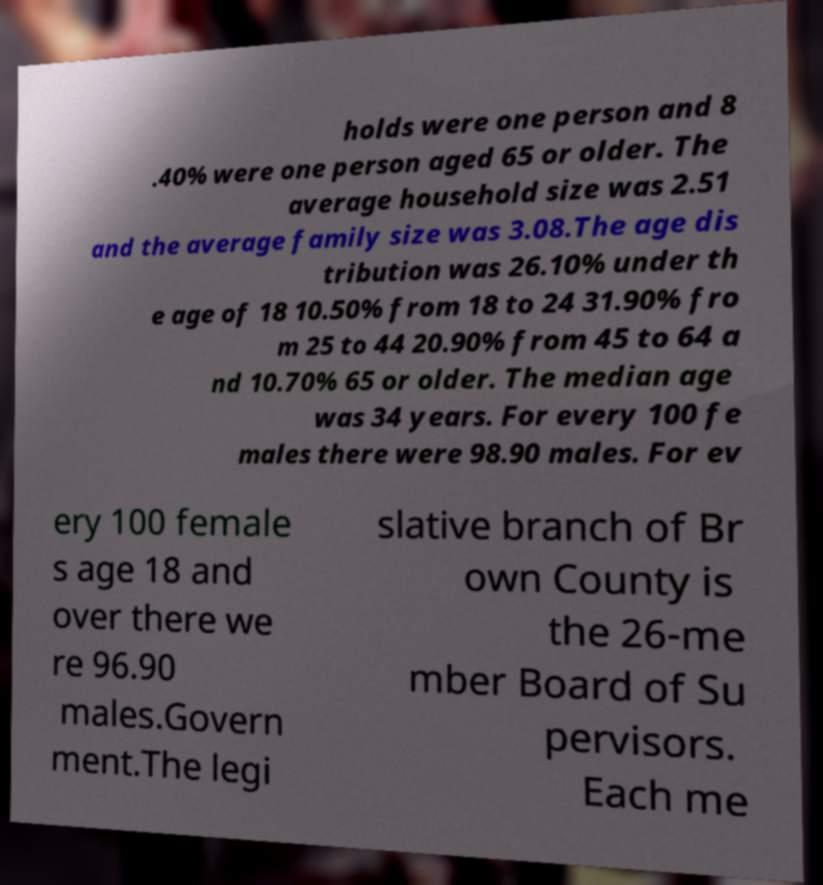For documentation purposes, I need the text within this image transcribed. Could you provide that? holds were one person and 8 .40% were one person aged 65 or older. The average household size was 2.51 and the average family size was 3.08.The age dis tribution was 26.10% under th e age of 18 10.50% from 18 to 24 31.90% fro m 25 to 44 20.90% from 45 to 64 a nd 10.70% 65 or older. The median age was 34 years. For every 100 fe males there were 98.90 males. For ev ery 100 female s age 18 and over there we re 96.90 males.Govern ment.The legi slative branch of Br own County is the 26-me mber Board of Su pervisors. Each me 